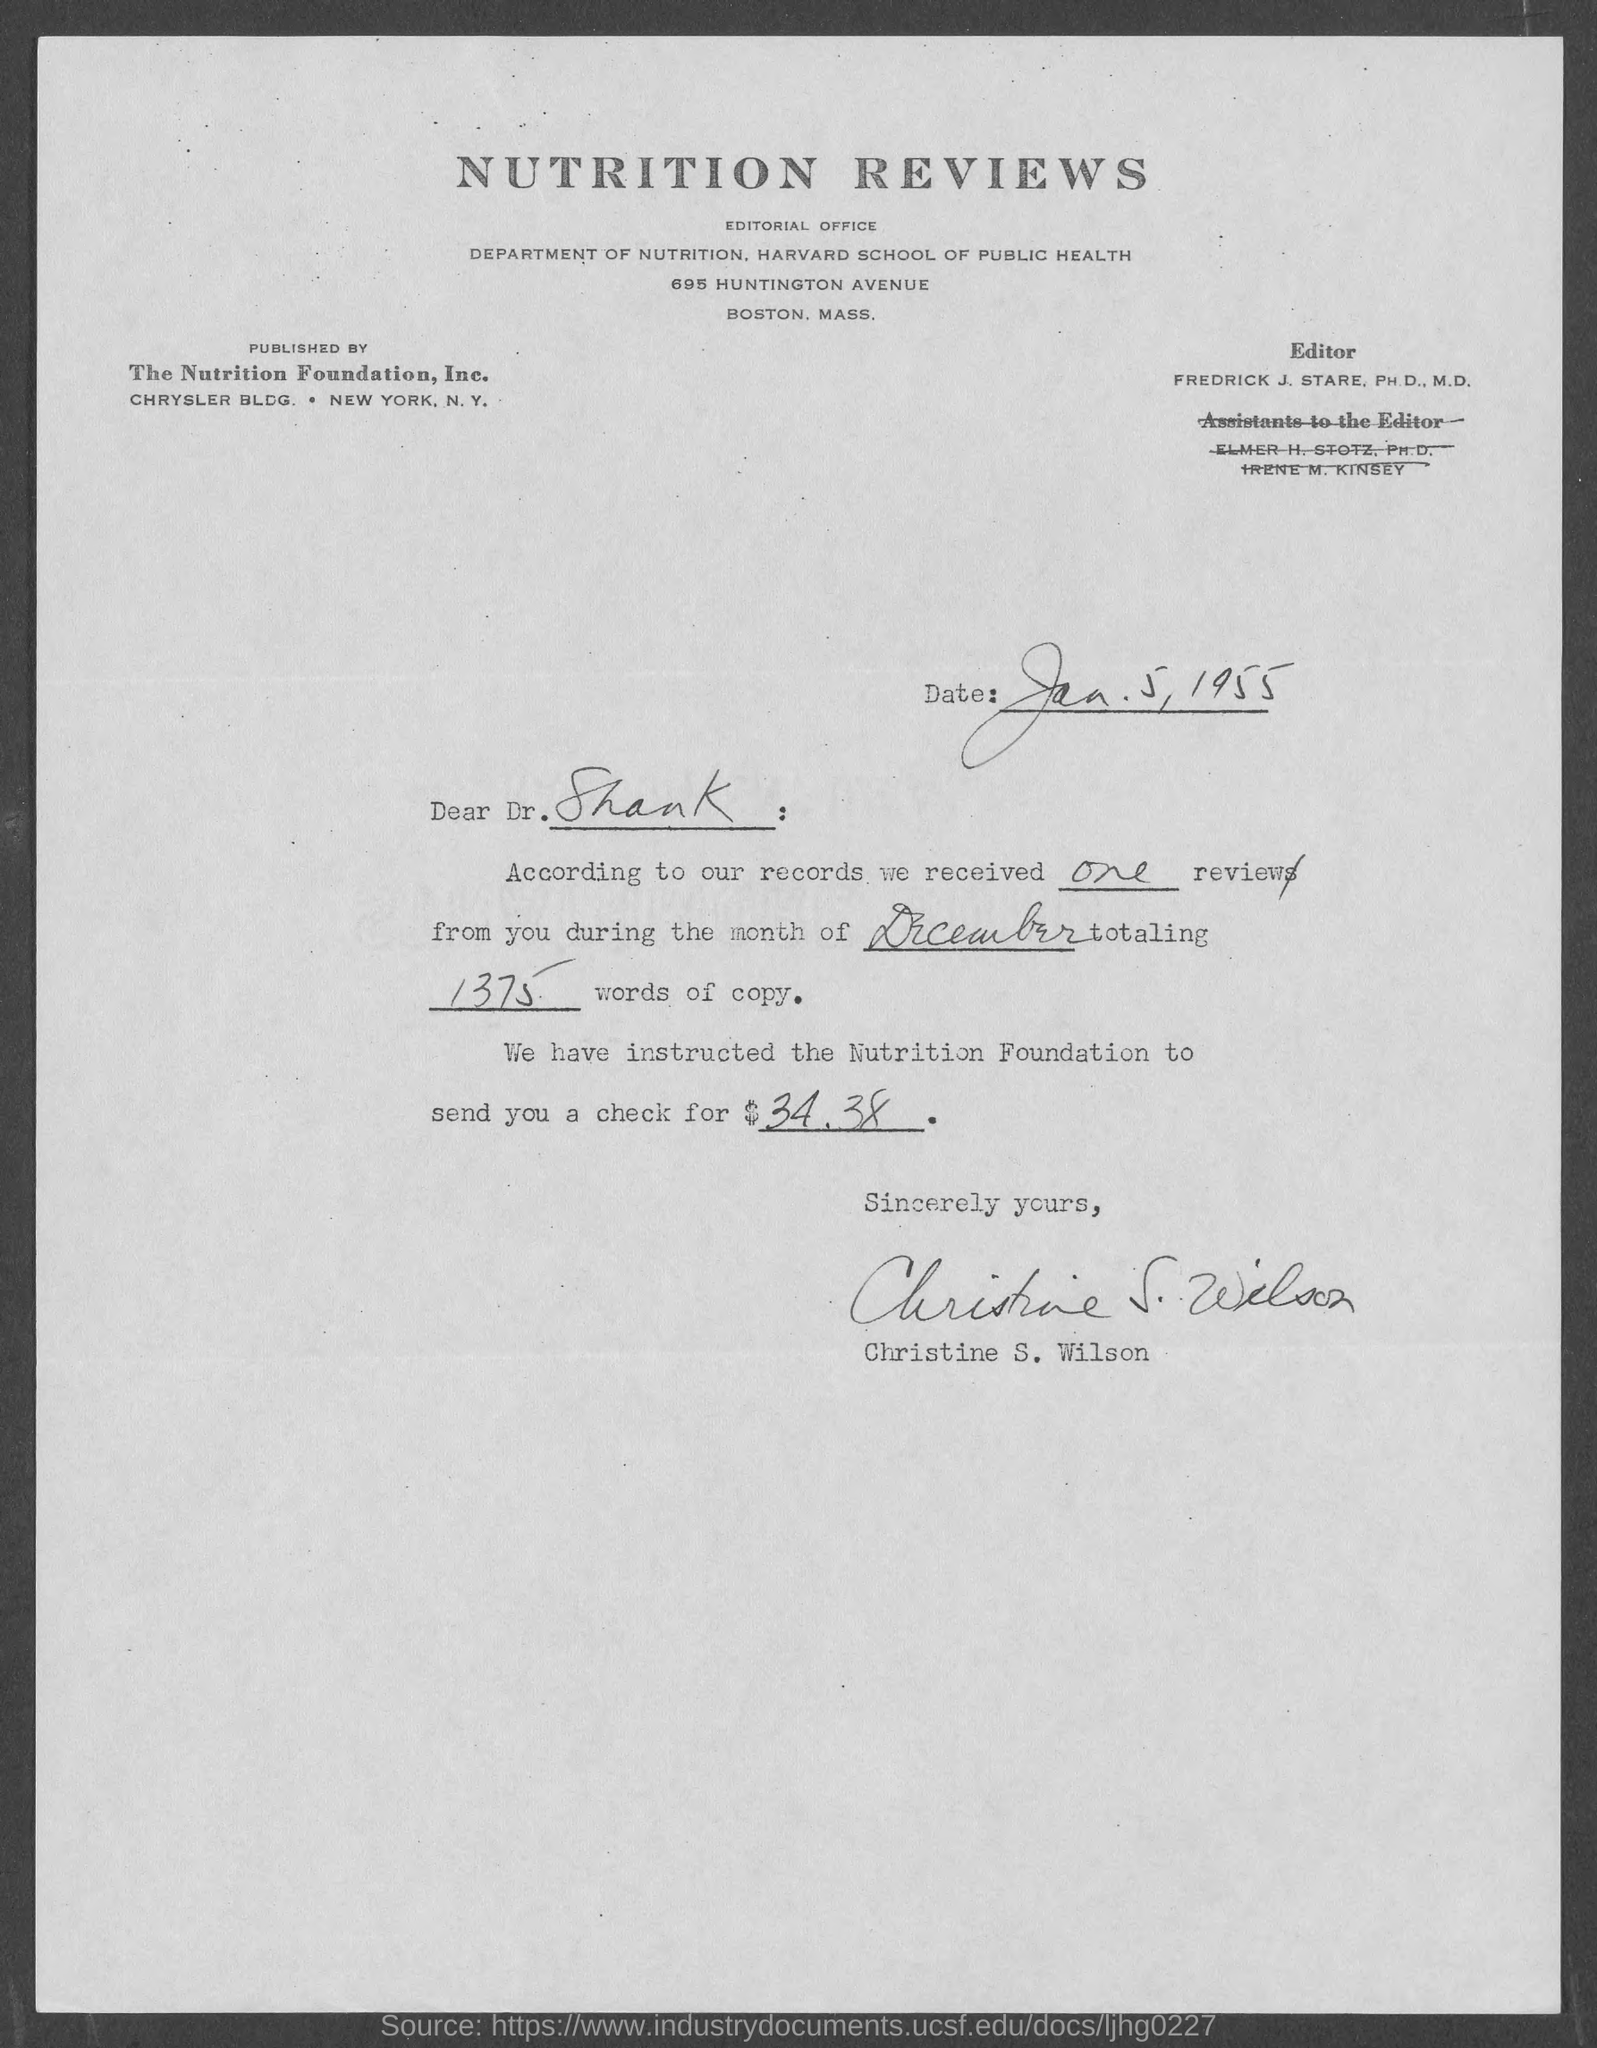What is the document title?
Give a very brief answer. NUTRITION REVIEWS. Who is the editor?
Your answer should be very brief. FREDRICK J. STARE, PH. D., M.D. Who is the publisher?
Ensure brevity in your answer.  The Nutrition Foundation, Inc. When is the document dated?
Offer a very short reply. Jan. 5, 1955. Who is the sender?
Provide a short and direct response. Christine S. Wilson. To whom is the letter addressed?
Ensure brevity in your answer.  Dr. Shank. How much is the check worth?
Ensure brevity in your answer.  34.38. 